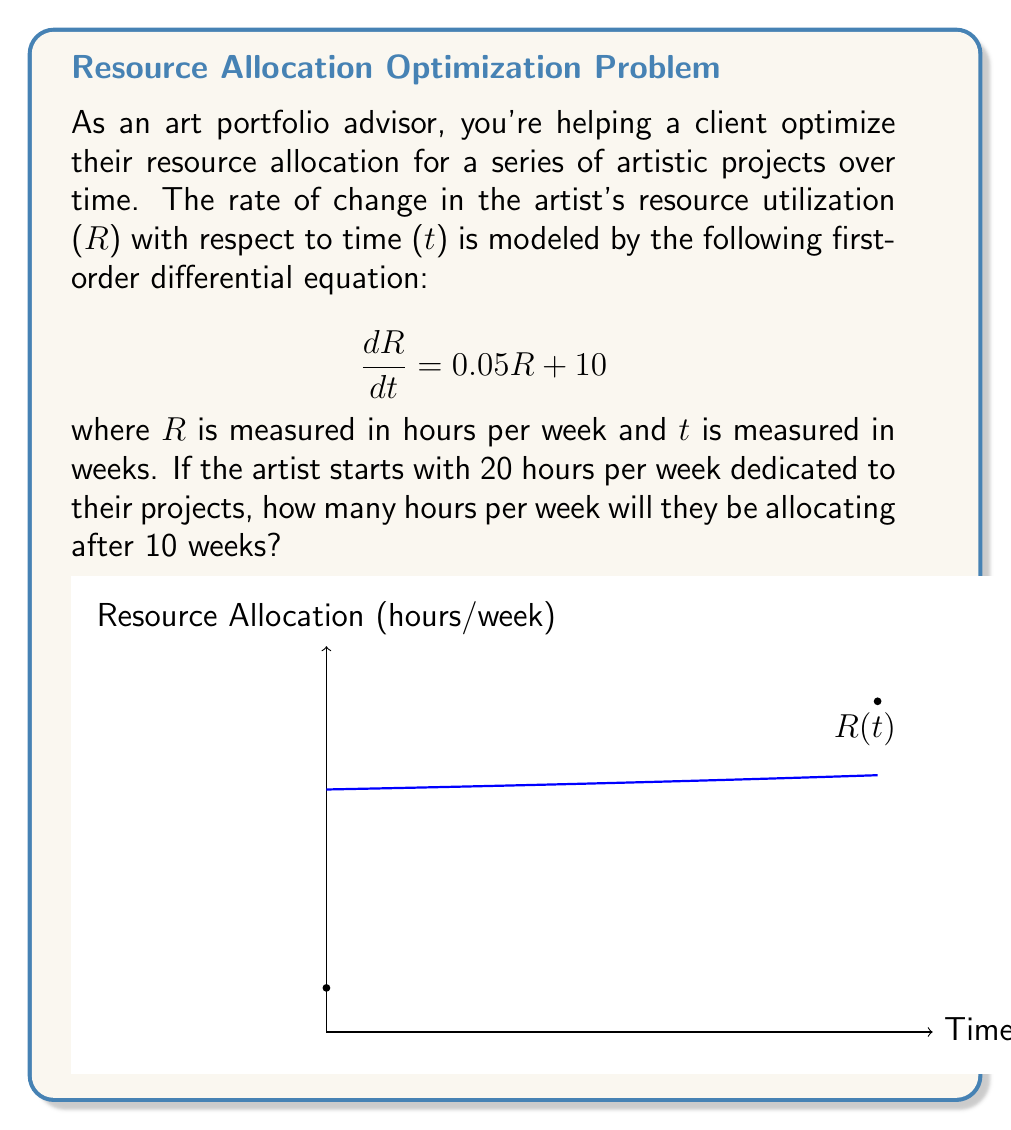Can you answer this question? To solve this problem, we need to follow these steps:

1) First, recognize that this is a linear first-order differential equation in the form:

   $$\frac{dR}{dt} = aR + b$$

   where $a = 0.05$ and $b = 10$.

2) The general solution for this type of equation is:

   $$R(t) = Ce^{at} - \frac{b}{a}$$

   where $C$ is a constant we need to determine.

3) Substituting our values:

   $$R(t) = Ce^{0.05t} - \frac{10}{0.05} = Ce^{0.05t} - 200$$

4) To find $C$, we use the initial condition: $R(0) = 20$

   $$20 = Ce^{0.05(0)} - 200$$
   $$20 = C - 200$$
   $$C = 220$$

5) Therefore, our particular solution is:

   $$R(t) = 220e^{0.05t} - 200$$

6) To find $R(10)$, we substitute $t = 10$:

   $$R(10) = 220e^{0.05(10)} - 200$$
   $$R(10) = 220e^{0.5} - 200$$
   $$R(10) = 220(1.6487) - 200$$
   $$R(10) = 362.714 - 200$$
   $$R(10) = 162.714$$

7) Rounding to the nearest hour:

   $$R(10) \approx 163 \text{ hours per week}$$
Answer: 163 hours per week 